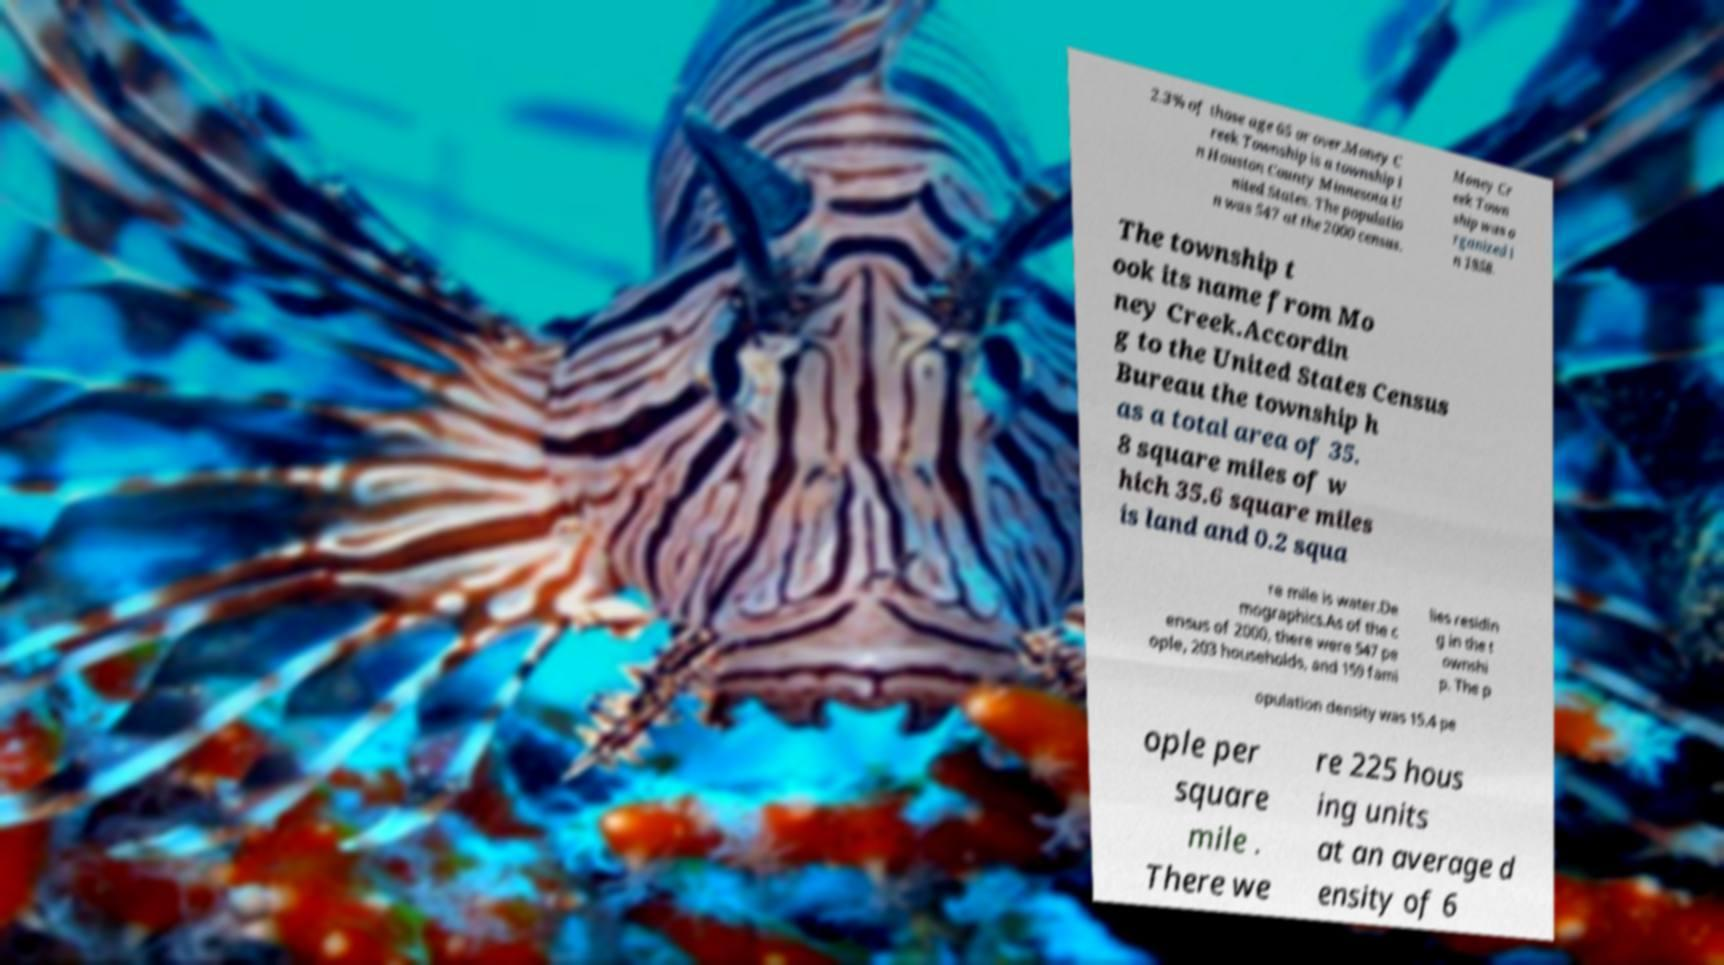Please identify and transcribe the text found in this image. 2.3% of those age 65 or over.Money C reek Township is a township i n Houston County Minnesota U nited States. The populatio n was 547 at the 2000 census. Money Cr eek Town ship was o rganized i n 1858. The township t ook its name from Mo ney Creek.Accordin g to the United States Census Bureau the township h as a total area of 35. 8 square miles of w hich 35.6 square miles is land and 0.2 squa re mile is water.De mographics.As of the c ensus of 2000, there were 547 pe ople, 203 households, and 159 fami lies residin g in the t ownshi p. The p opulation density was 15.4 pe ople per square mile . There we re 225 hous ing units at an average d ensity of 6 